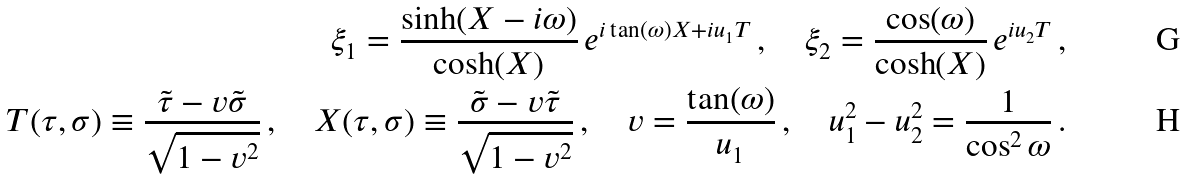Convert formula to latex. <formula><loc_0><loc_0><loc_500><loc_500>\xi _ { 1 } = \frac { \sinh ( X - i \omega ) } { \cosh ( X ) } \, e ^ { i \tan ( \omega ) X + i u _ { 1 } T } \, , \quad \xi _ { 2 } = \frac { \cos ( \omega ) } { \cosh ( X ) } \, e ^ { i u _ { 2 } T } \, , \\ T ( \tau , \sigma ) \equiv \frac { \tilde { \tau } - v \tilde { \sigma } } { \sqrt { 1 - v ^ { 2 } } } \, , \quad X ( \tau , \sigma ) \equiv \frac { \tilde { \sigma } - v \tilde { \tau } } { \sqrt { 1 - v ^ { 2 } } } \, , \quad v = \frac { \tan ( \omega ) } { u _ { 1 } } \, , \quad u _ { 1 } ^ { 2 } - u _ { 2 } ^ { 2 } = \frac { 1 } { \cos ^ { 2 } \omega } \, .</formula> 